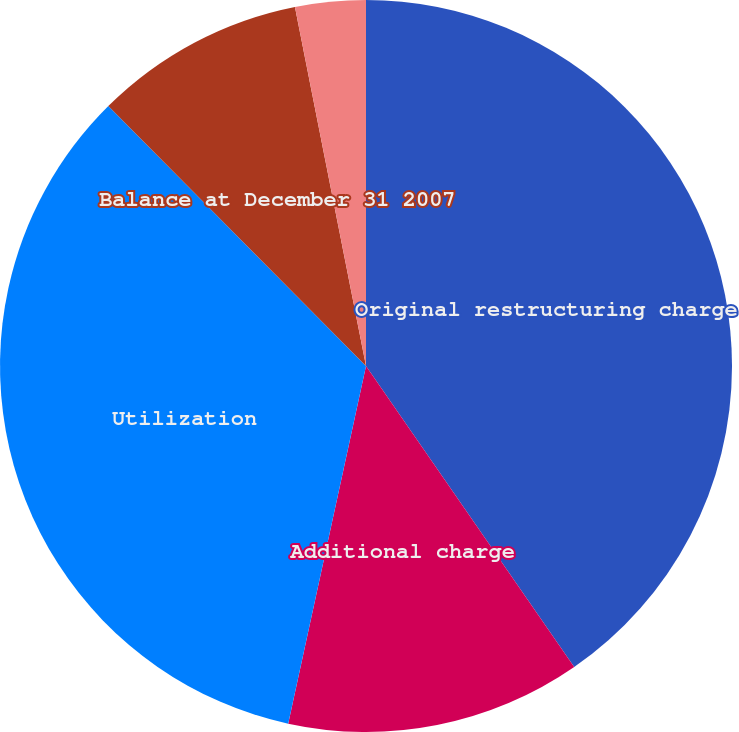Convert chart. <chart><loc_0><loc_0><loc_500><loc_500><pie_chart><fcel>Original restructuring charge<fcel>Additional charge<fcel>Utilization<fcel>Balance at December 31 2007<fcel>Changes in estimates<nl><fcel>40.37%<fcel>13.04%<fcel>34.16%<fcel>9.32%<fcel>3.11%<nl></chart> 